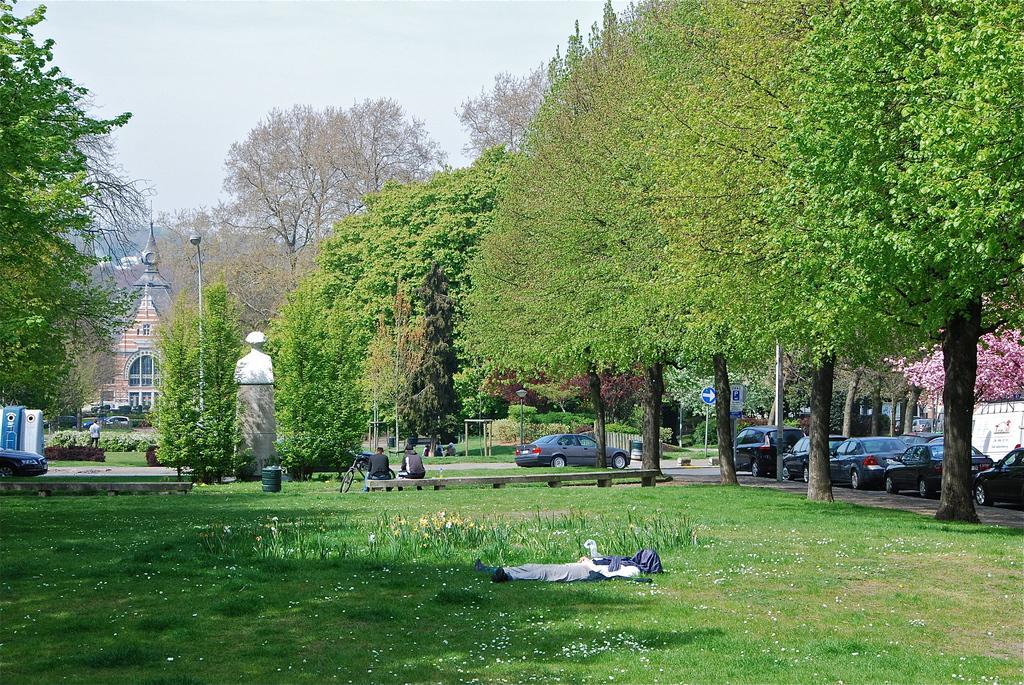Could you give a brief overview of what you see in this image? This picture is clicked outside. In the foreground we can see the ground is covered with the green grass and there are some objects placed on the ground and there are two persons sitting on the bench and there are some vehicles parked on the ground and we can see the lights attached to the poles. In the background there is a sky, trees and buildings. 